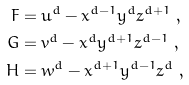<formula> <loc_0><loc_0><loc_500><loc_500>F & = u ^ { d } - x ^ { d - 1 } y ^ { d } z ^ { d + 1 } \ , \\ G & = v ^ { d } - x ^ { d } y ^ { d + 1 } z ^ { d - 1 } \ , \\ H & = w ^ { d } - x ^ { d + 1 } y ^ { d - 1 } z ^ { d } \ ,</formula> 